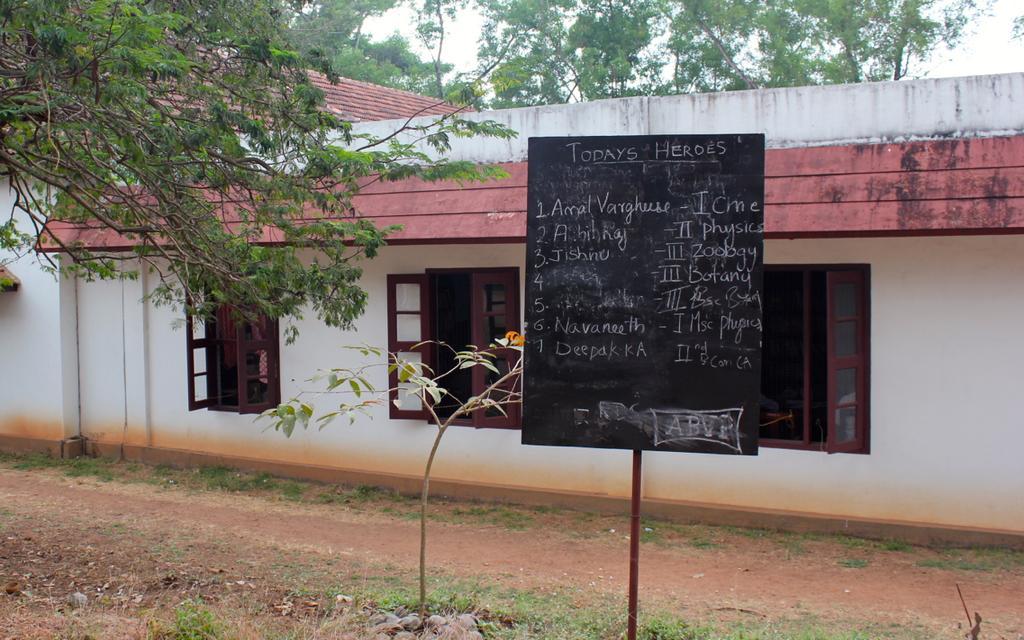Could you give a brief overview of what you see in this image? In this image there is the sky towards the top of the image, there are trees towards the top of the image, there is a building, there are windows, there is a wall, there is a pole towards the bottom of the image, there is a board, there is text on the board, there is a plant, there's grass on the ground. 